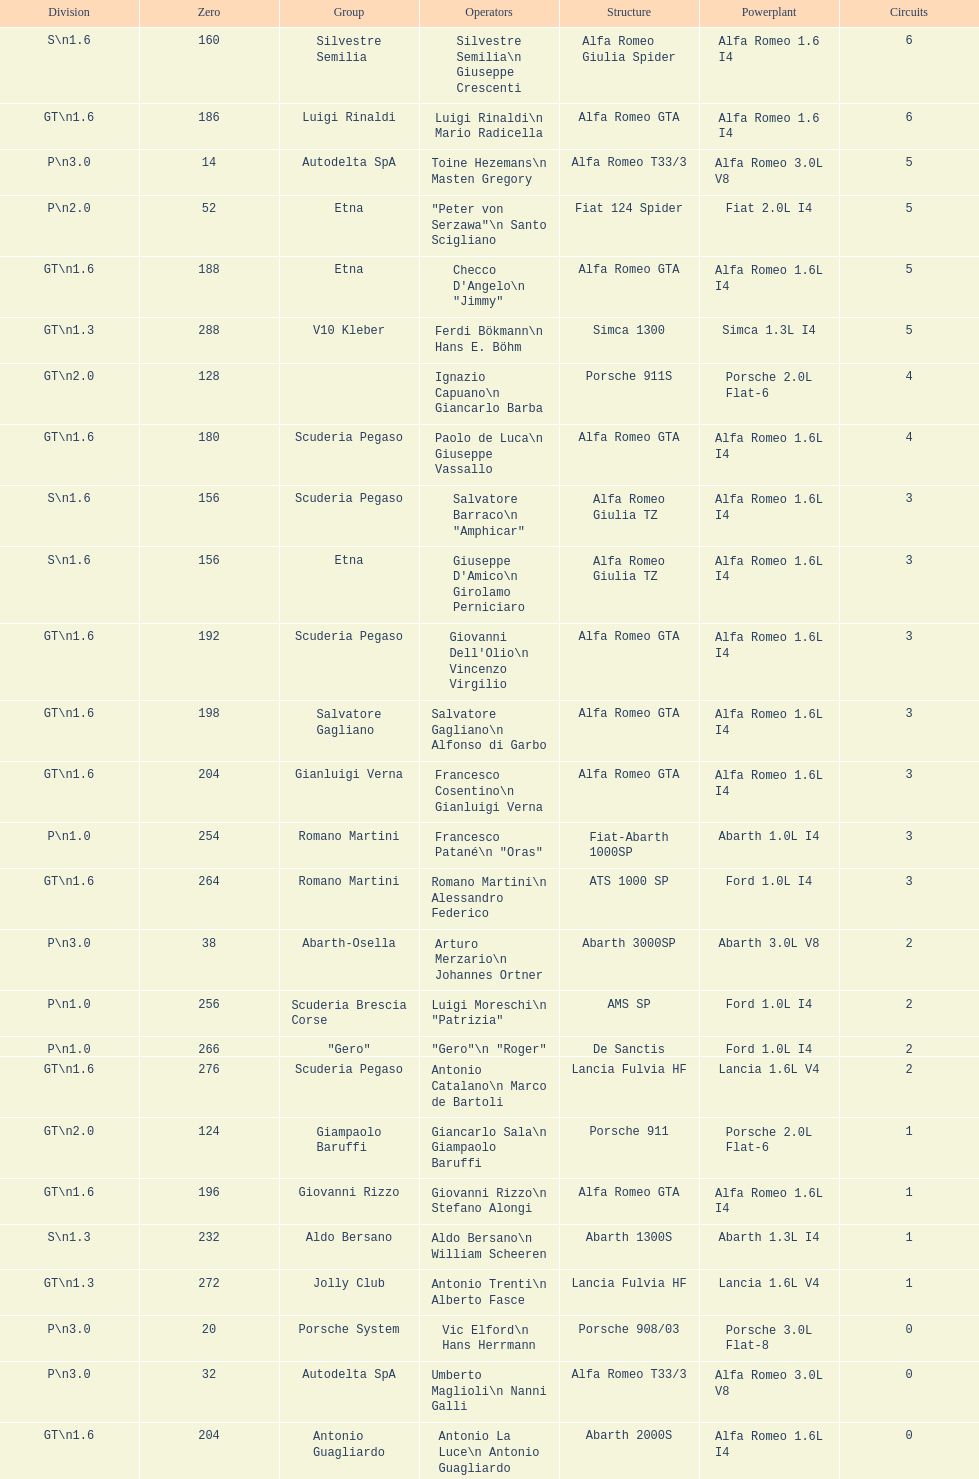How many teams failed to finish the race after 2 laps? 4. 